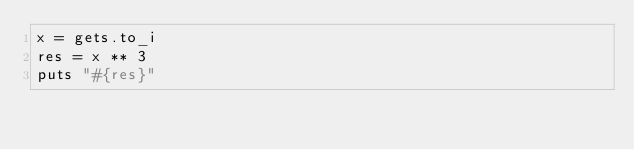Convert code to text. <code><loc_0><loc_0><loc_500><loc_500><_Ruby_>x = gets.to_i
res = x ** 3
puts "#{res}"</code> 